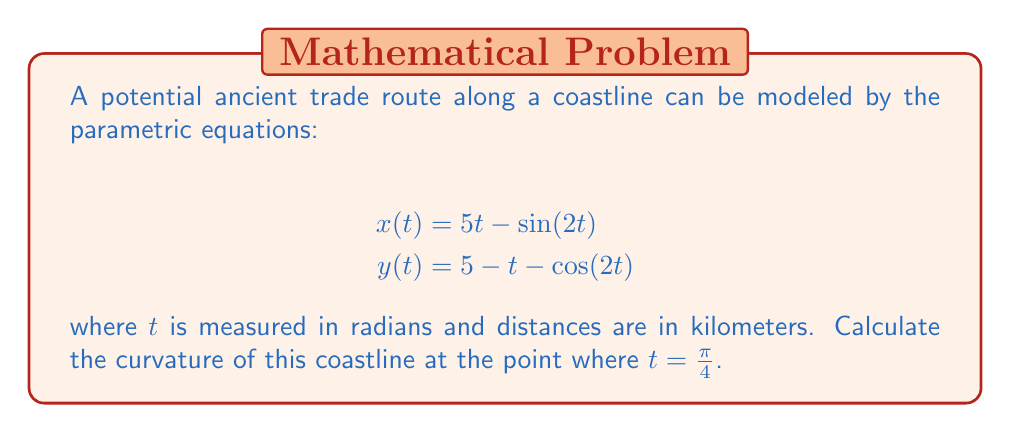Could you help me with this problem? To find the curvature of a parametric curve at a given point, we can use the formula:

$$\kappa = \frac{|x'y'' - y'x''|}{(x'^2 + y'^2)^{3/2}}$$

Let's follow these steps:

1) First, we need to find $x'(t)$, $y'(t)$, $x''(t)$, and $y''(t)$:

   $$x'(t) = 5 - 2\cos(2t)$$
   $$y'(t) = -1 + 2\sin(2t)$$
   $$x''(t) = 4\sin(2t)$$
   $$y''(t) = 4\cos(2t)$$

2) Now, let's evaluate these at $t = \frac{\pi}{4}$:

   $$x'(\frac{\pi}{4}) = 5 - 2\cos(\frac{\pi}{2}) = 5$$
   $$y'(\frac{\pi}{4}) = -1 + 2\sin(\frac{\pi}{2}) = 1$$
   $$x''(\frac{\pi}{4}) = 4\sin(\frac{\pi}{2}) = 4$$
   $$y''(\frac{\pi}{4}) = 4\cos(\frac{\pi}{2}) = 0$$

3) Now we can substitute these values into our curvature formula:

   $$\kappa = \frac{|x'y'' - y'x''|}{(x'^2 + y'^2)^{3/2}}$$
   $$\kappa = \frac{|5(0) - 1(4)|}{(5^2 + 1^2)^{3/2}}$$
   $$\kappa = \frac{4}{(26)^{3/2}}$$

4) Simplify:
   $$\kappa = \frac{4}{26\sqrt{26}}$$

This is the curvature of the coastline at the point where $t = \frac{\pi}{4}$.
Answer: $$\kappa = \frac{4}{26\sqrt{26}} \approx 0.0302 \text{ km}^{-1}$$ 